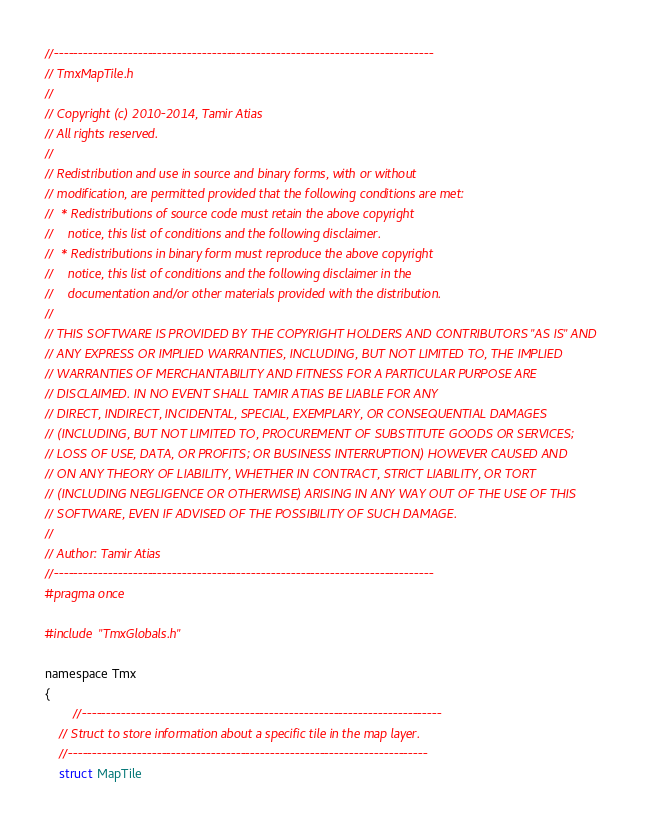<code> <loc_0><loc_0><loc_500><loc_500><_C_>//-----------------------------------------------------------------------------
// TmxMapTile.h
//
// Copyright (c) 2010-2014, Tamir Atias
// All rights reserved.
//
// Redistribution and use in source and binary forms, with or without
// modification, are permitted provided that the following conditions are met:
//  * Redistributions of source code must retain the above copyright
//    notice, this list of conditions and the following disclaimer.
//  * Redistributions in binary form must reproduce the above copyright
//    notice, this list of conditions and the following disclaimer in the
//    documentation and/or other materials provided with the distribution.
//
// THIS SOFTWARE IS PROVIDED BY THE COPYRIGHT HOLDERS AND CONTRIBUTORS "AS IS" AND
// ANY EXPRESS OR IMPLIED WARRANTIES, INCLUDING, BUT NOT LIMITED TO, THE IMPLIED
// WARRANTIES OF MERCHANTABILITY AND FITNESS FOR A PARTICULAR PURPOSE ARE
// DISCLAIMED. IN NO EVENT SHALL TAMIR ATIAS BE LIABLE FOR ANY
// DIRECT, INDIRECT, INCIDENTAL, SPECIAL, EXEMPLARY, OR CONSEQUENTIAL DAMAGES
// (INCLUDING, BUT NOT LIMITED TO, PROCUREMENT OF SUBSTITUTE GOODS OR SERVICES;
// LOSS OF USE, DATA, OR PROFITS; OR BUSINESS INTERRUPTION) HOWEVER CAUSED AND
// ON ANY THEORY OF LIABILITY, WHETHER IN CONTRACT, STRICT LIABILITY, OR TORT
// (INCLUDING NEGLIGENCE OR OTHERWISE) ARISING IN ANY WAY OUT OF THE USE OF THIS
// SOFTWARE, EVEN IF ADVISED OF THE POSSIBILITY OF SUCH DAMAGE.
//
// Author: Tamir Atias
//-----------------------------------------------------------------------------
#pragma once

#include "TmxGlobals.h"

namespace Tmx 
{
		//-------------------------------------------------------------------------
	// Struct to store information about a specific tile in the map layer.
	//-------------------------------------------------------------------------
	struct MapTile </code> 